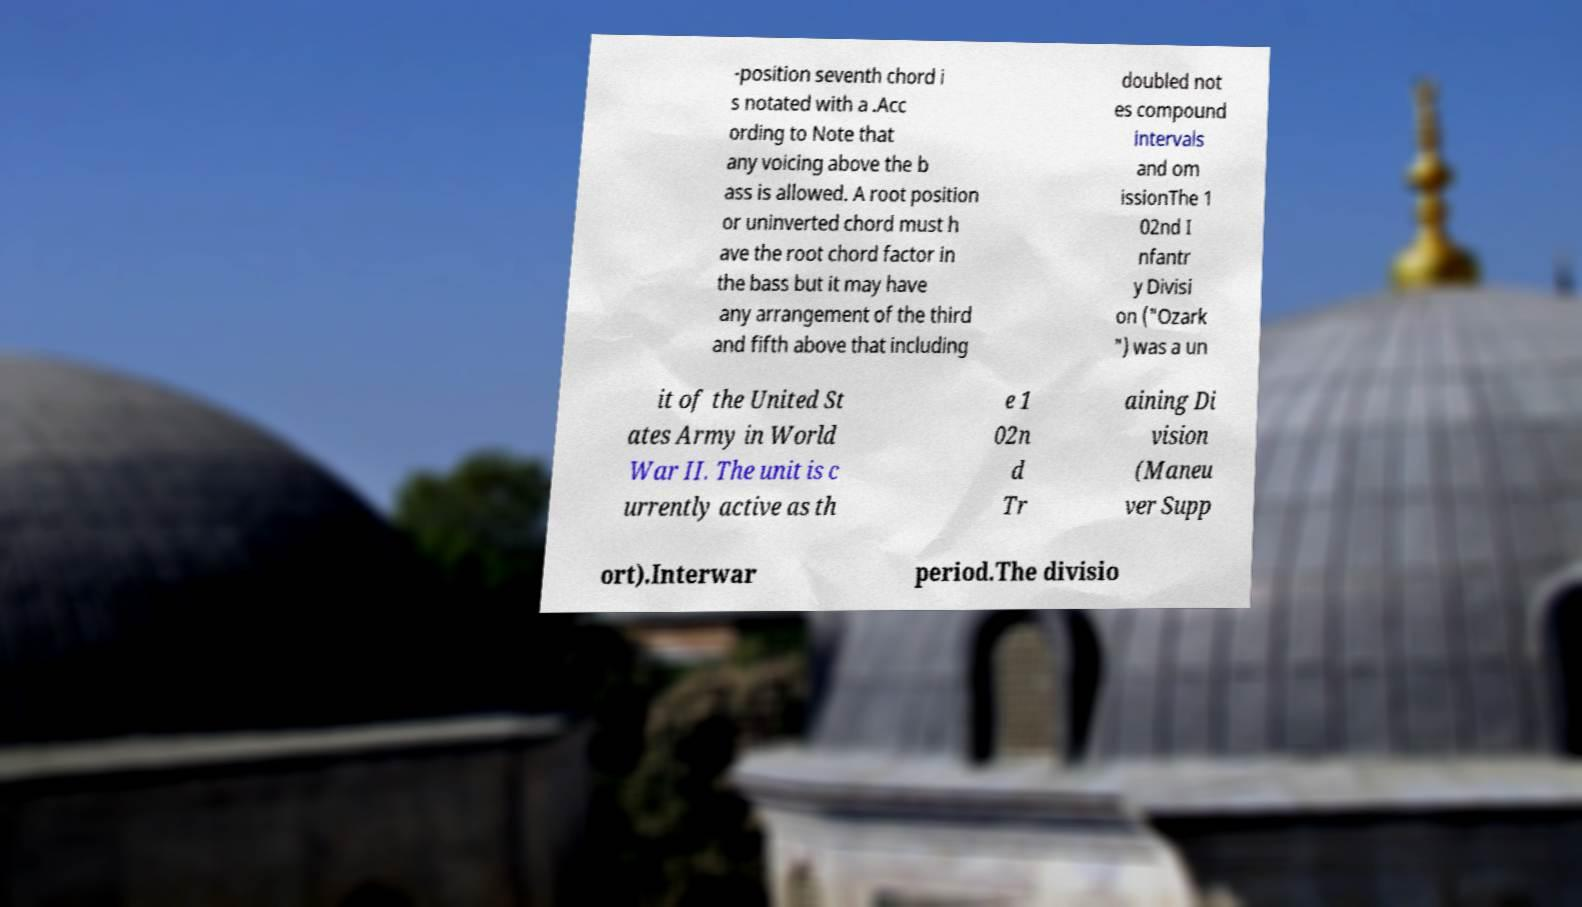Can you accurately transcribe the text from the provided image for me? -position seventh chord i s notated with a .Acc ording to Note that any voicing above the b ass is allowed. A root position or uninverted chord must h ave the root chord factor in the bass but it may have any arrangement of the third and fifth above that including doubled not es compound intervals and om issionThe 1 02nd I nfantr y Divisi on ("Ozark ") was a un it of the United St ates Army in World War II. The unit is c urrently active as th e 1 02n d Tr aining Di vision (Maneu ver Supp ort).Interwar period.The divisio 